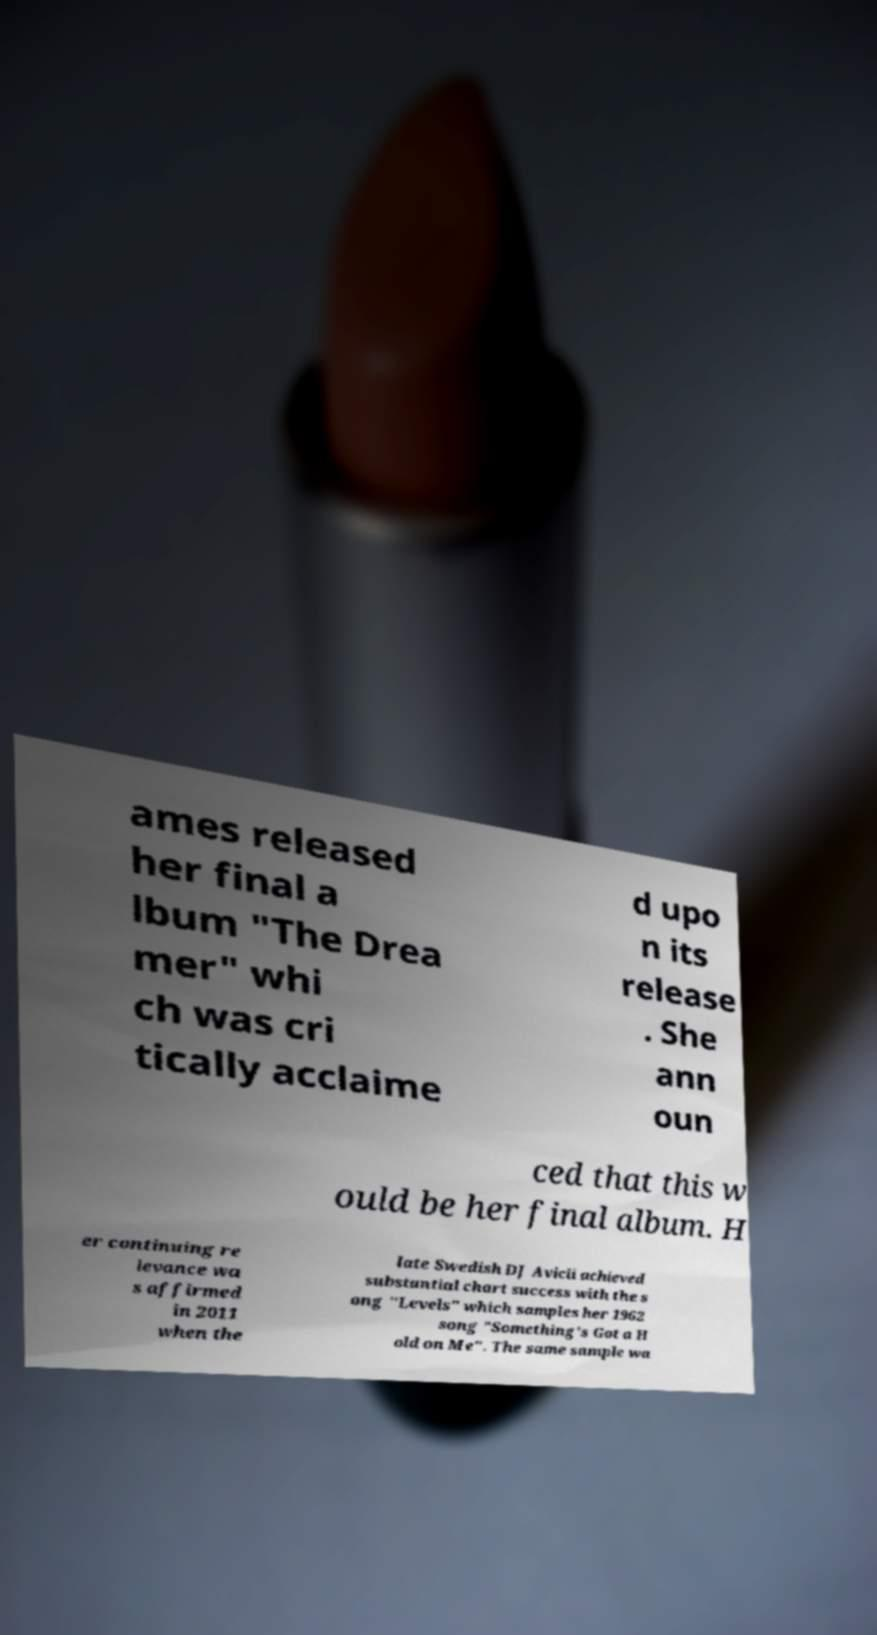For documentation purposes, I need the text within this image transcribed. Could you provide that? ames released her final a lbum "The Drea mer" whi ch was cri tically acclaime d upo n its release . She ann oun ced that this w ould be her final album. H er continuing re levance wa s affirmed in 2011 when the late Swedish DJ Avicii achieved substantial chart success with the s ong "Levels" which samples her 1962 song "Something's Got a H old on Me". The same sample wa 